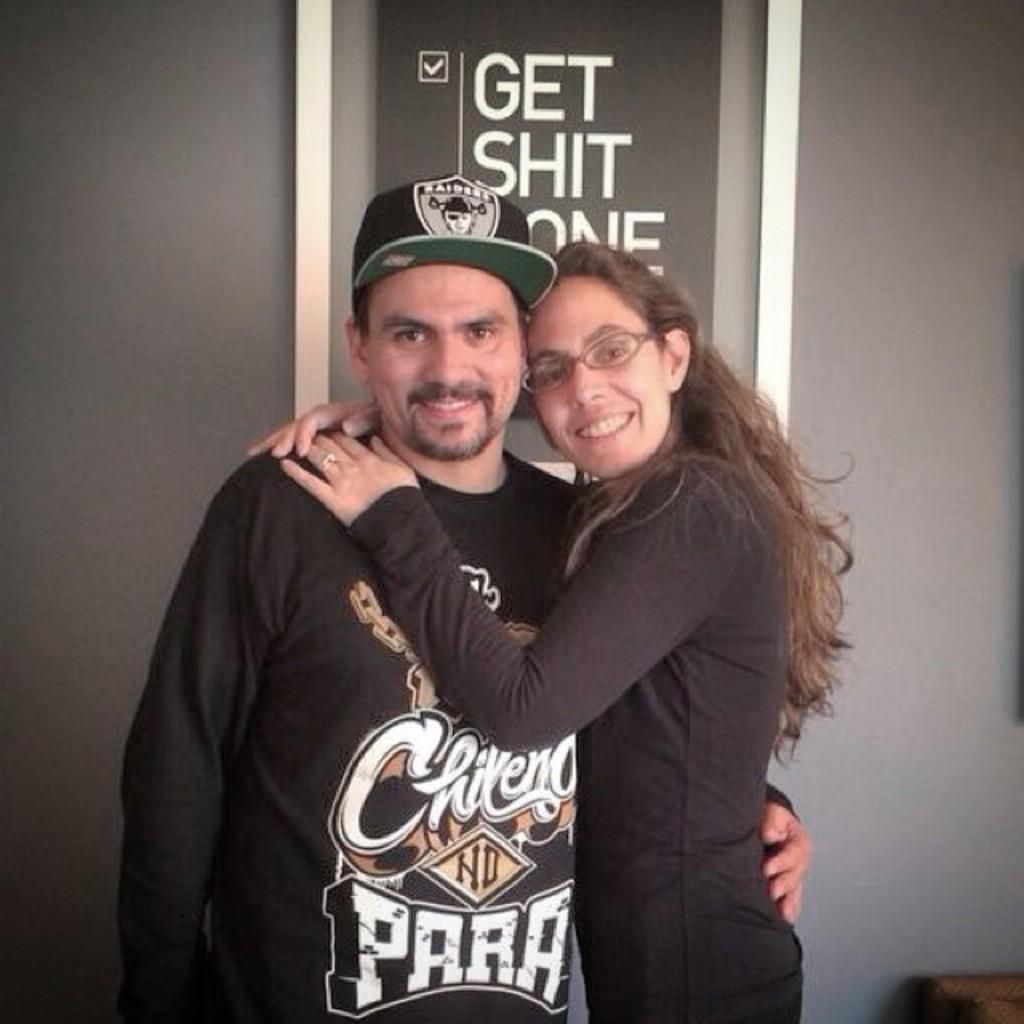Provide a one-sentence caption for the provided image. A young couple pose in front of a poster instructing people to Get Shit Done. 